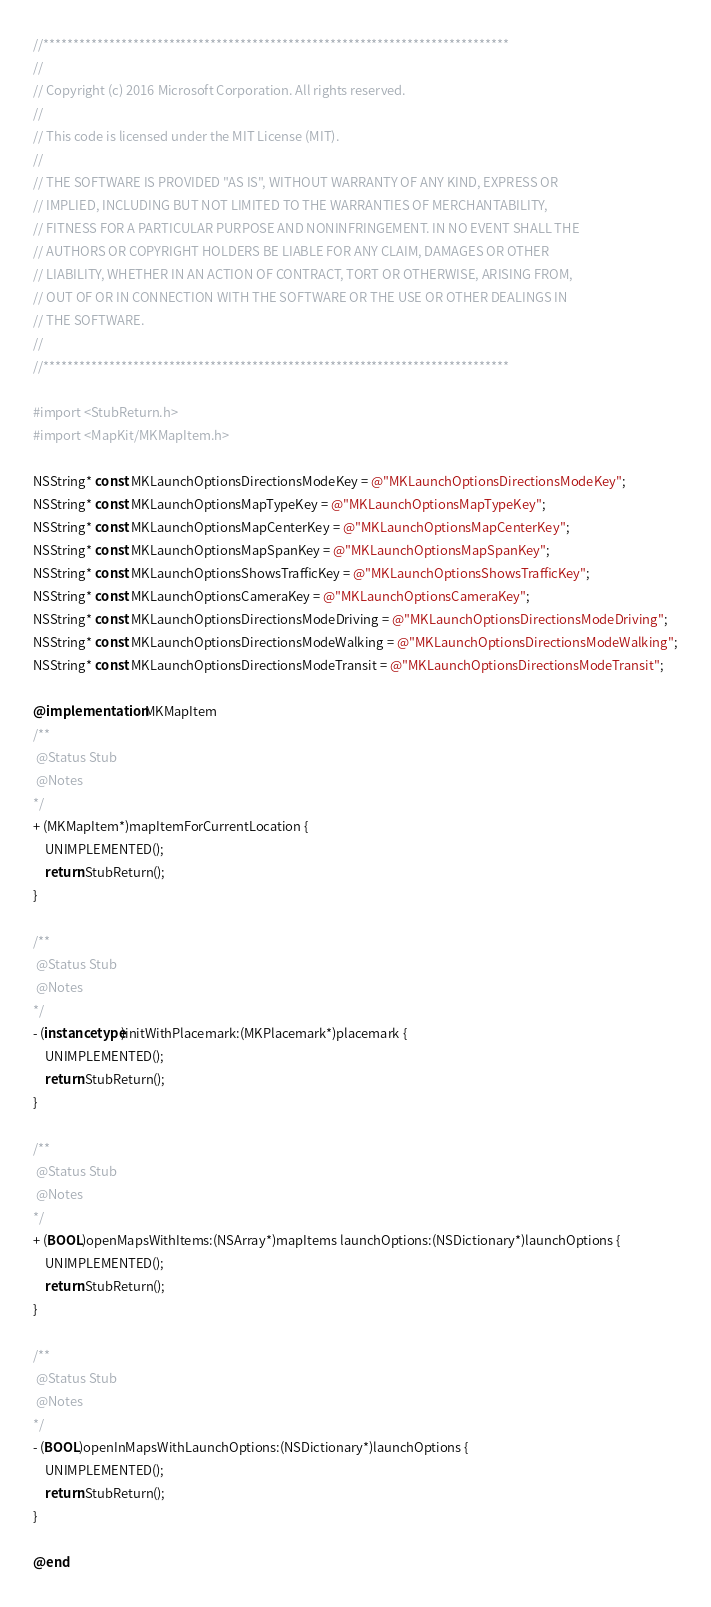Convert code to text. <code><loc_0><loc_0><loc_500><loc_500><_ObjectiveC_>//******************************************************************************
//
// Copyright (c) 2016 Microsoft Corporation. All rights reserved.
//
// This code is licensed under the MIT License (MIT).
//
// THE SOFTWARE IS PROVIDED "AS IS", WITHOUT WARRANTY OF ANY KIND, EXPRESS OR
// IMPLIED, INCLUDING BUT NOT LIMITED TO THE WARRANTIES OF MERCHANTABILITY,
// FITNESS FOR A PARTICULAR PURPOSE AND NONINFRINGEMENT. IN NO EVENT SHALL THE
// AUTHORS OR COPYRIGHT HOLDERS BE LIABLE FOR ANY CLAIM, DAMAGES OR OTHER
// LIABILITY, WHETHER IN AN ACTION OF CONTRACT, TORT OR OTHERWISE, ARISING FROM,
// OUT OF OR IN CONNECTION WITH THE SOFTWARE OR THE USE OR OTHER DEALINGS IN
// THE SOFTWARE.
//
//******************************************************************************

#import <StubReturn.h>
#import <MapKit/MKMapItem.h>

NSString* const MKLaunchOptionsDirectionsModeKey = @"MKLaunchOptionsDirectionsModeKey";
NSString* const MKLaunchOptionsMapTypeKey = @"MKLaunchOptionsMapTypeKey";
NSString* const MKLaunchOptionsMapCenterKey = @"MKLaunchOptionsMapCenterKey";
NSString* const MKLaunchOptionsMapSpanKey = @"MKLaunchOptionsMapSpanKey";
NSString* const MKLaunchOptionsShowsTrafficKey = @"MKLaunchOptionsShowsTrafficKey";
NSString* const MKLaunchOptionsCameraKey = @"MKLaunchOptionsCameraKey";
NSString* const MKLaunchOptionsDirectionsModeDriving = @"MKLaunchOptionsDirectionsModeDriving";
NSString* const MKLaunchOptionsDirectionsModeWalking = @"MKLaunchOptionsDirectionsModeWalking";
NSString* const MKLaunchOptionsDirectionsModeTransit = @"MKLaunchOptionsDirectionsModeTransit";

@implementation MKMapItem
/**
 @Status Stub
 @Notes
*/
+ (MKMapItem*)mapItemForCurrentLocation {
    UNIMPLEMENTED();
    return StubReturn();
}

/**
 @Status Stub
 @Notes
*/
- (instancetype)initWithPlacemark:(MKPlacemark*)placemark {
    UNIMPLEMENTED();
    return StubReturn();
}

/**
 @Status Stub
 @Notes
*/
+ (BOOL)openMapsWithItems:(NSArray*)mapItems launchOptions:(NSDictionary*)launchOptions {
    UNIMPLEMENTED();
    return StubReturn();
}

/**
 @Status Stub
 @Notes
*/
- (BOOL)openInMapsWithLaunchOptions:(NSDictionary*)launchOptions {
    UNIMPLEMENTED();
    return StubReturn();
}

@end
</code> 